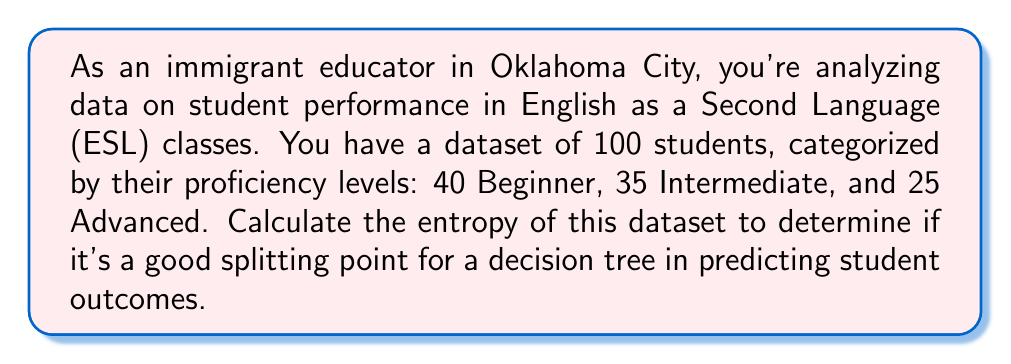Can you answer this question? To calculate the entropy of the dataset, we'll use the formula:

$$H = -\sum_{i=1}^{n} p_i \log_2(p_i)$$

Where:
- $H$ is the entropy
- $n$ is the number of classes (in this case, 3: Beginner, Intermediate, and Advanced)
- $p_i$ is the probability of an instance belonging to class $i$

Step 1: Calculate the probabilities for each class
- $p_{Beginner} = 40/100 = 0.4$
- $p_{Intermediate} = 35/100 = 0.35$
- $p_{Advanced} = 25/100 = 0.25$

Step 2: Apply the entropy formula
$$\begin{align*}
H &= -[p_{Beginner} \log_2(p_{Beginner}) + p_{Intermediate} \log_2(p_{Intermediate}) + p_{Advanced} \log_2(p_{Advanced})] \\
&= -[0.4 \log_2(0.4) + 0.35 \log_2(0.35) + 0.25 \log_2(0.25)] \\
&= -[0.4 \cdot (-1.3219) + 0.35 \cdot (-1.5146) + 0.25 \cdot (-2)] \\
&= -[-0.52876 - 0.53011 - 0.5] \\
&= 1.55887
\end{align*}$$

Step 3: Interpret the result
The maximum entropy for a 3-class problem is $\log_2(3) \approx 1.5850$. Our calculated entropy (1.55887) is very close to this maximum, indicating that the dataset is well-balanced and has high uncertainty. This suggests that this splitting point could be effective for a decision tree, as it provides a good amount of information gain potential for further splits.
Answer: The entropy of the dataset is approximately 1.55887 bits. 